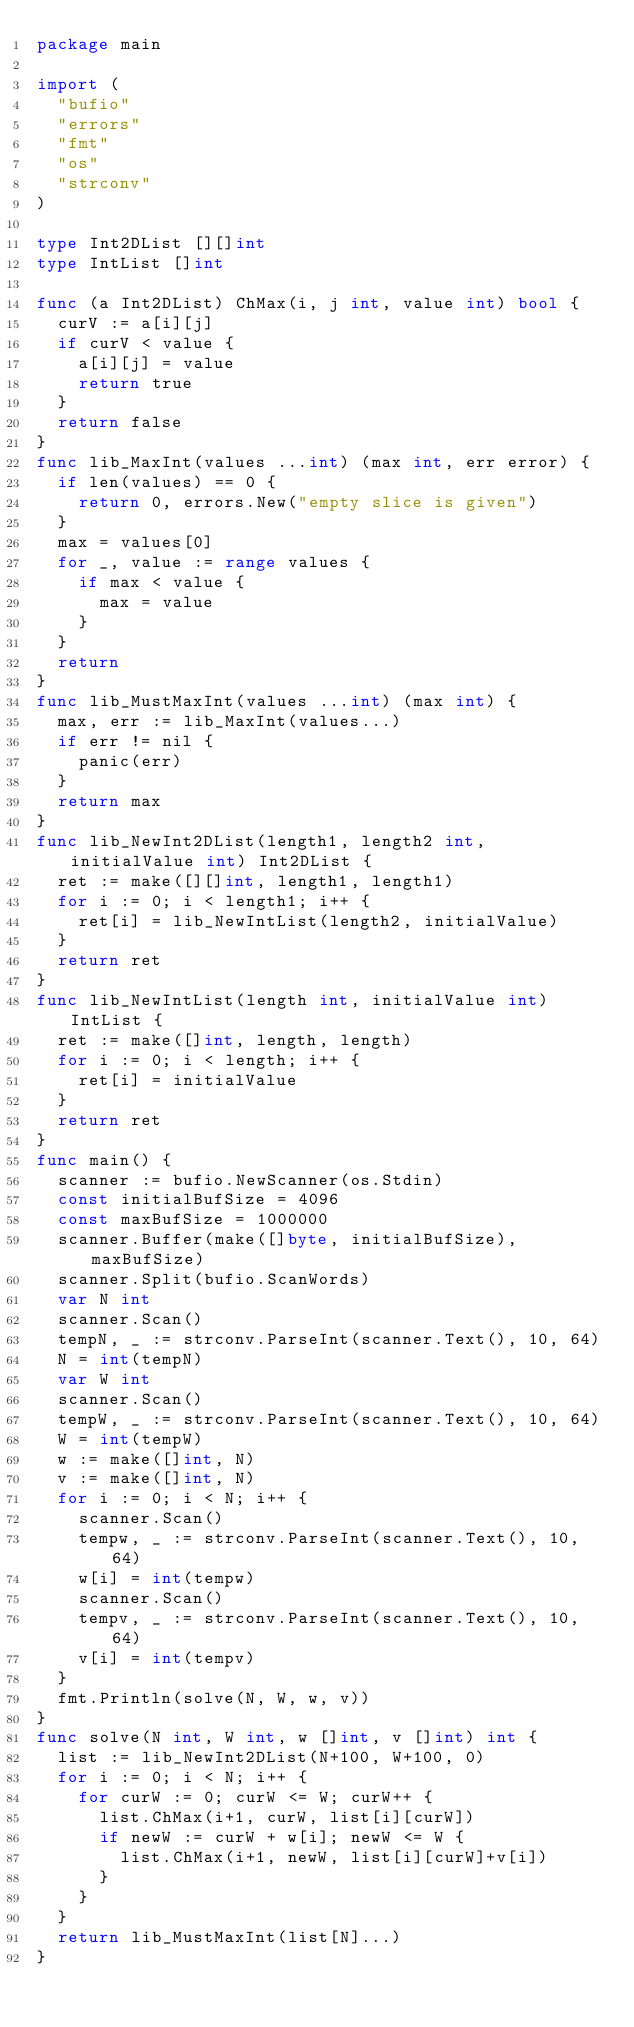Convert code to text. <code><loc_0><loc_0><loc_500><loc_500><_Go_>package main

import (
	"bufio"
	"errors"
	"fmt"
	"os"
	"strconv"
)

type Int2DList [][]int
type IntList []int

func (a Int2DList) ChMax(i, j int, value int) bool {
	curV := a[i][j]
	if curV < value {
		a[i][j] = value
		return true
	}
	return false
}
func lib_MaxInt(values ...int) (max int, err error) {
	if len(values) == 0 {
		return 0, errors.New("empty slice is given")
	}
	max = values[0]
	for _, value := range values {
		if max < value {
			max = value
		}
	}
	return
}
func lib_MustMaxInt(values ...int) (max int) {
	max, err := lib_MaxInt(values...)
	if err != nil {
		panic(err)
	}
	return max
}
func lib_NewInt2DList(length1, length2 int, initialValue int) Int2DList {
	ret := make([][]int, length1, length1)
	for i := 0; i < length1; i++ {
		ret[i] = lib_NewIntList(length2, initialValue)
	}
	return ret
}
func lib_NewIntList(length int, initialValue int) IntList {
	ret := make([]int, length, length)
	for i := 0; i < length; i++ {
		ret[i] = initialValue
	}
	return ret
}
func main() {
	scanner := bufio.NewScanner(os.Stdin)
	const initialBufSize = 4096
	const maxBufSize = 1000000
	scanner.Buffer(make([]byte, initialBufSize), maxBufSize)
	scanner.Split(bufio.ScanWords)
	var N int
	scanner.Scan()
	tempN, _ := strconv.ParseInt(scanner.Text(), 10, 64)
	N = int(tempN)
	var W int
	scanner.Scan()
	tempW, _ := strconv.ParseInt(scanner.Text(), 10, 64)
	W = int(tempW)
	w := make([]int, N)
	v := make([]int, N)
	for i := 0; i < N; i++ {
		scanner.Scan()
		tempw, _ := strconv.ParseInt(scanner.Text(), 10, 64)
		w[i] = int(tempw)
		scanner.Scan()
		tempv, _ := strconv.ParseInt(scanner.Text(), 10, 64)
		v[i] = int(tempv)
	}
	fmt.Println(solve(N, W, w, v))
}
func solve(N int, W int, w []int, v []int) int {
	list := lib_NewInt2DList(N+100, W+100, 0)
	for i := 0; i < N; i++ {
		for curW := 0; curW <= W; curW++ {
			list.ChMax(i+1, curW, list[i][curW])
			if newW := curW + w[i]; newW <= W {
				list.ChMax(i+1, newW, list[i][curW]+v[i])
			}
		}
	}
	return lib_MustMaxInt(list[N]...)
}
</code> 